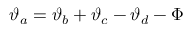Convert formula to latex. <formula><loc_0><loc_0><loc_500><loc_500>\vartheta _ { a } = \vartheta _ { b } + \vartheta _ { c } - \vartheta _ { d } - \Phi</formula> 